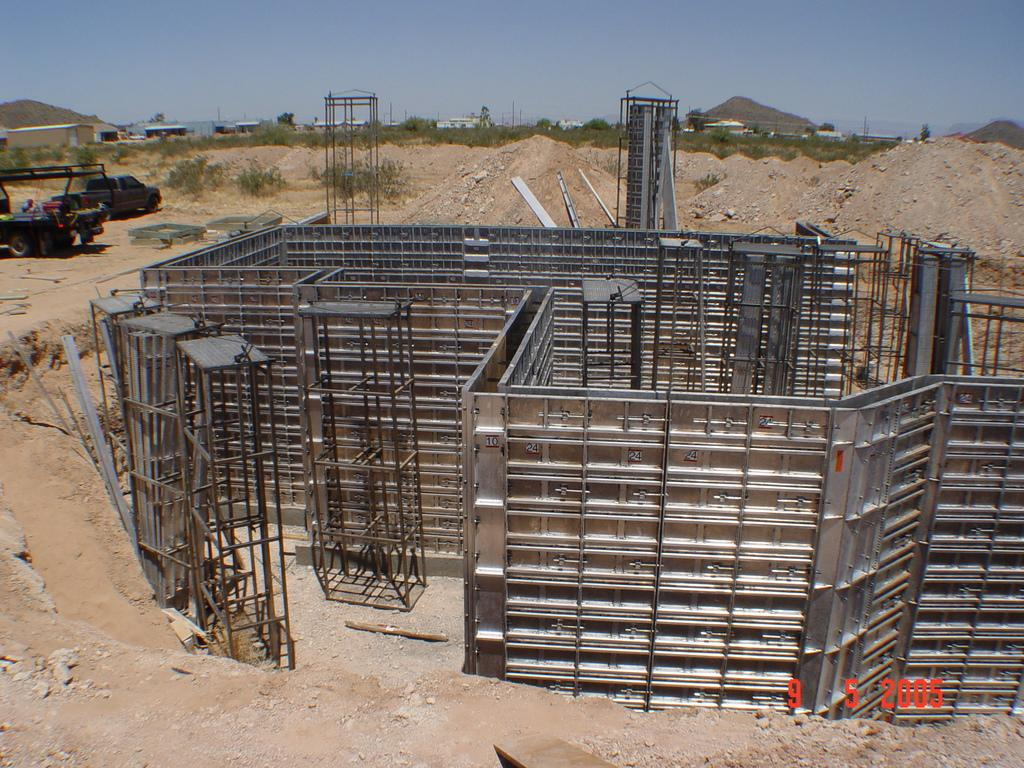What type of building is in the image? There is a constricting building in the image. What else can be seen in the image besides the building? Vehicles, trees, and houses are visible in the image. What type of bulb is used to light up the building in the image? There is no information about the type of bulb used to light up the building in the image. Additionally, the image does not show any bulbs or lighting fixtures. 